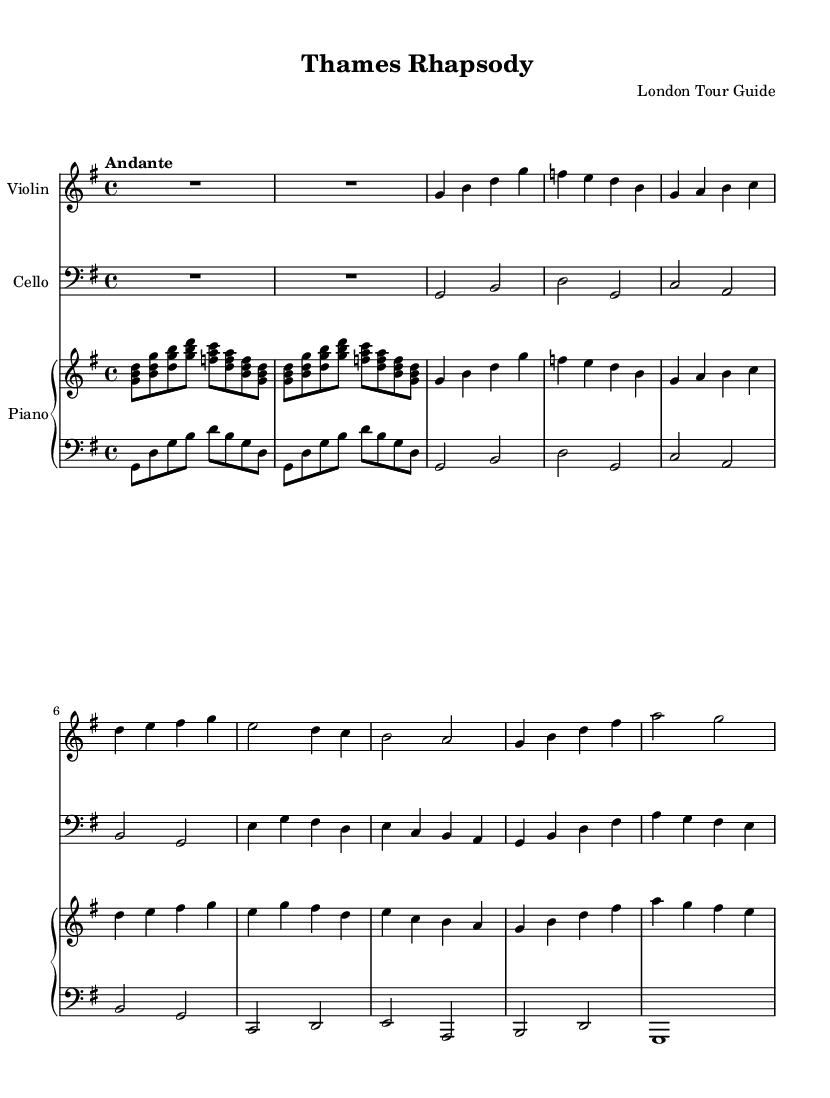What is the key signature of this music? The key signature is G major, which has one sharp (F#). This can be determined by looking at the key signature notated at the beginning of the staff.
Answer: G major What is the time signature of the piece? The time signature is 4/4, indicating there are four beats in each measure and a quarter note gets one beat. This is visible at the start of the music.
Answer: 4/4 What is the tempo marking for this composition? The tempo marking is Andante, signifying a moderately slow pace. This is indicated at the beginning of the sheet music right after the time signature.
Answer: Andante How many themes are present in the piece? There are two distinct themes, labeled as Theme A and Theme B in the music. This can be identified by their individual sections indicated in the score.
Answer: 2 In which sections do the violin and cello have rest? The violin and cello have a rest during the introduction, which is marked with a whole note rest for two measures at the beginning. This is the only occurrence where they are silent.
Answer: Introduction What is the highest pitch in the violin part? The highest pitch in the violin part is C, located in the fourth measure of Theme A. This can be identified by examining the note heads in that section of the score.
Answer: C What chords are played during the introduction in the piano part? The chords played during the introduction in the piano part are G major, F major, and D minor, all of which can be identified in the chord notation of the right hand during this section.
Answer: G major, F major, D minor 